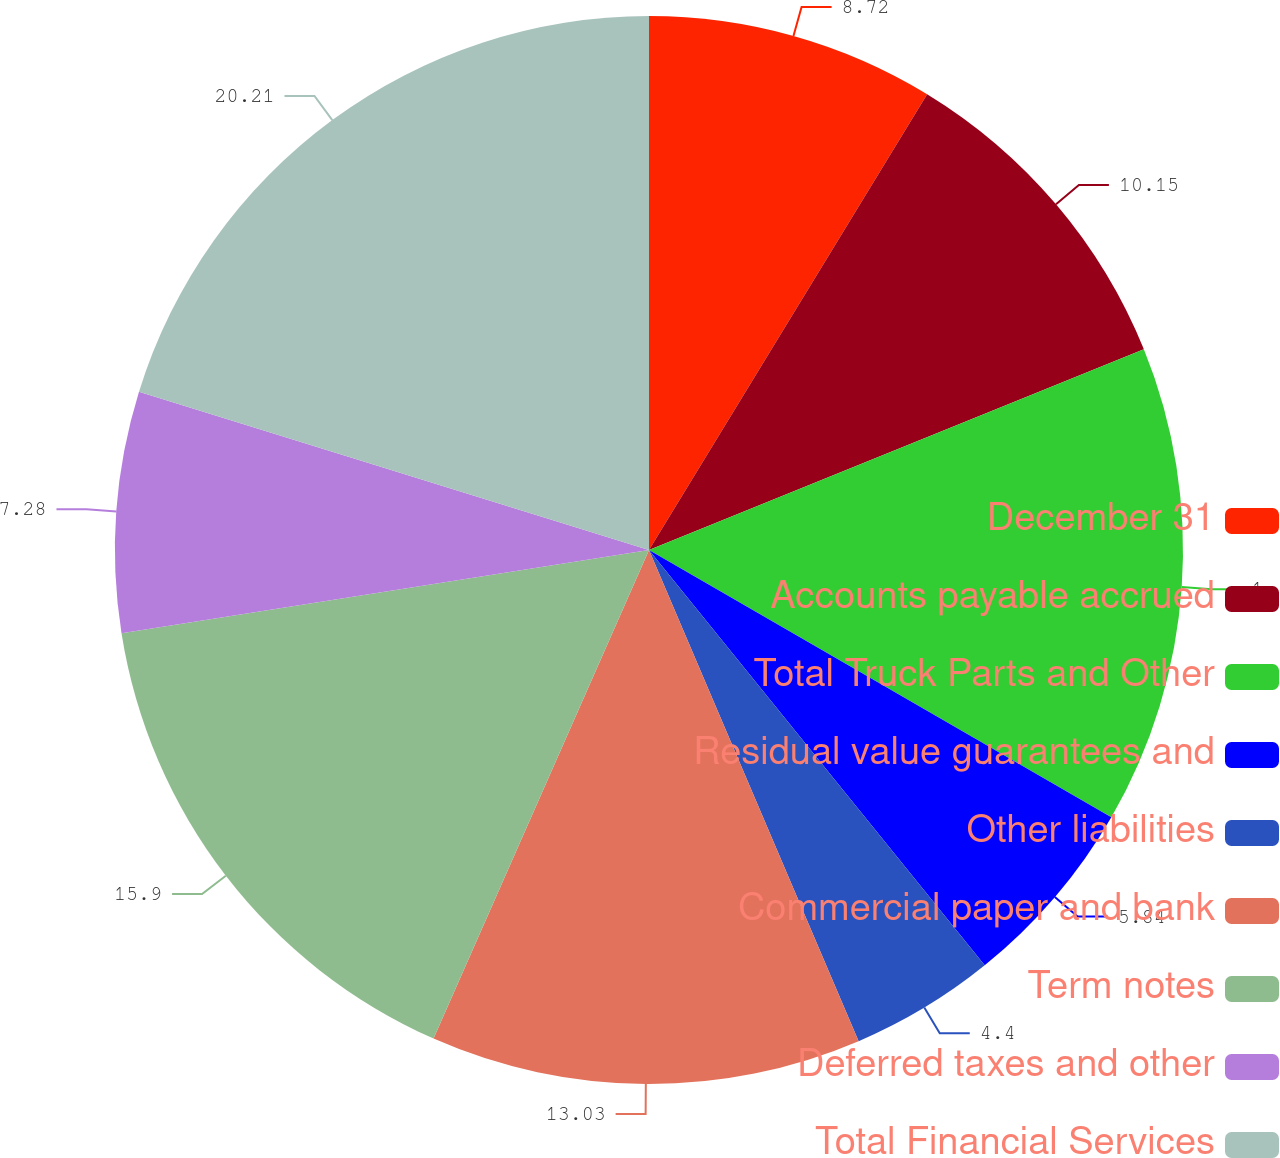Convert chart. <chart><loc_0><loc_0><loc_500><loc_500><pie_chart><fcel>December 31<fcel>Accounts payable accrued<fcel>Total Truck Parts and Other<fcel>Residual value guarantees and<fcel>Other liabilities<fcel>Commercial paper and bank<fcel>Term notes<fcel>Deferred taxes and other<fcel>Total Financial Services<nl><fcel>8.72%<fcel>10.15%<fcel>14.47%<fcel>5.84%<fcel>4.4%<fcel>13.03%<fcel>15.9%<fcel>7.28%<fcel>20.21%<nl></chart> 